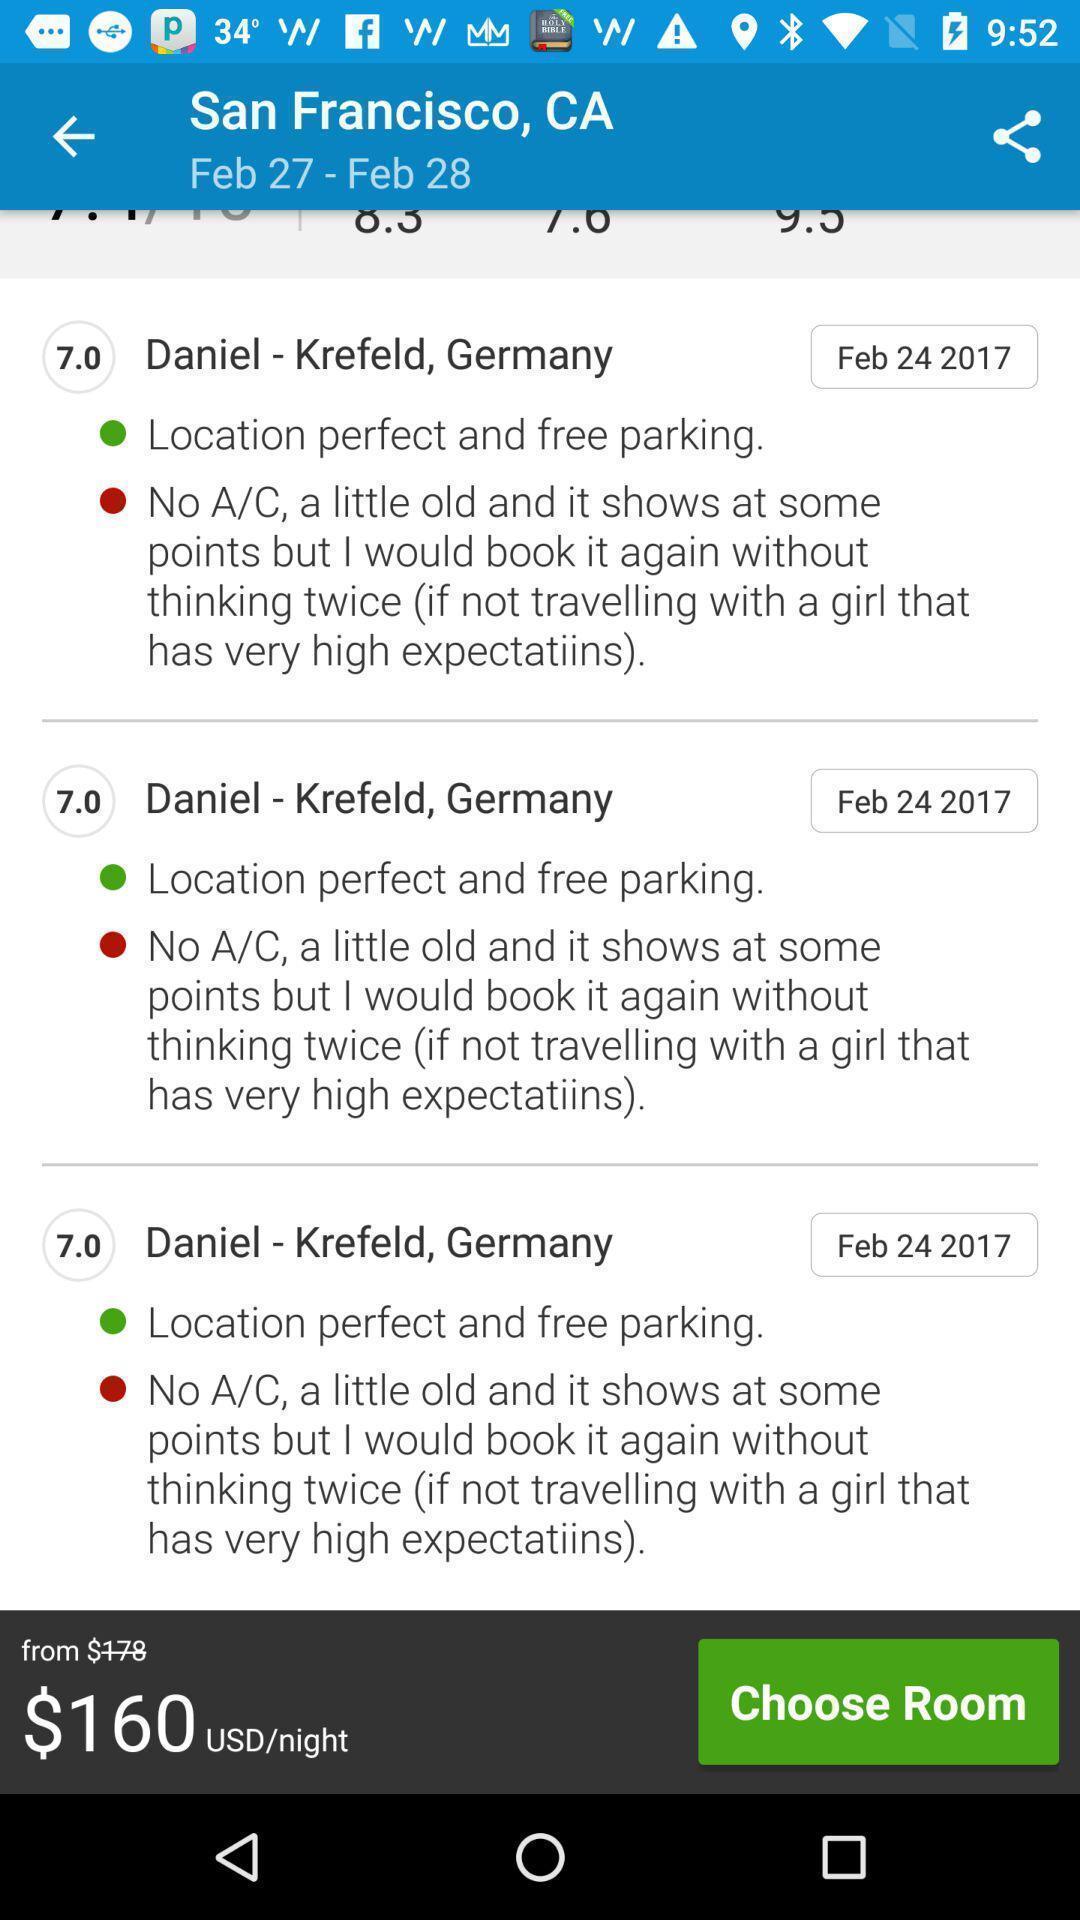Summarize the information in this screenshot. Screen shows hotel details in accommodation app. 